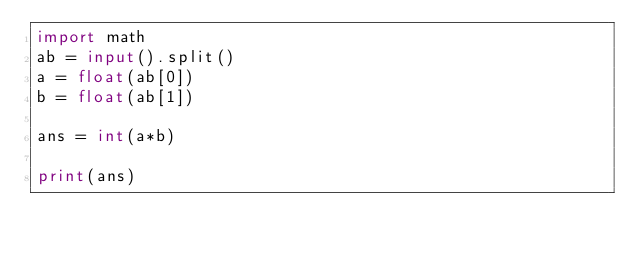Convert code to text. <code><loc_0><loc_0><loc_500><loc_500><_Python_>import math
ab = input().split()
a = float(ab[0])
b = float(ab[1])

ans = int(a*b)

print(ans)</code> 